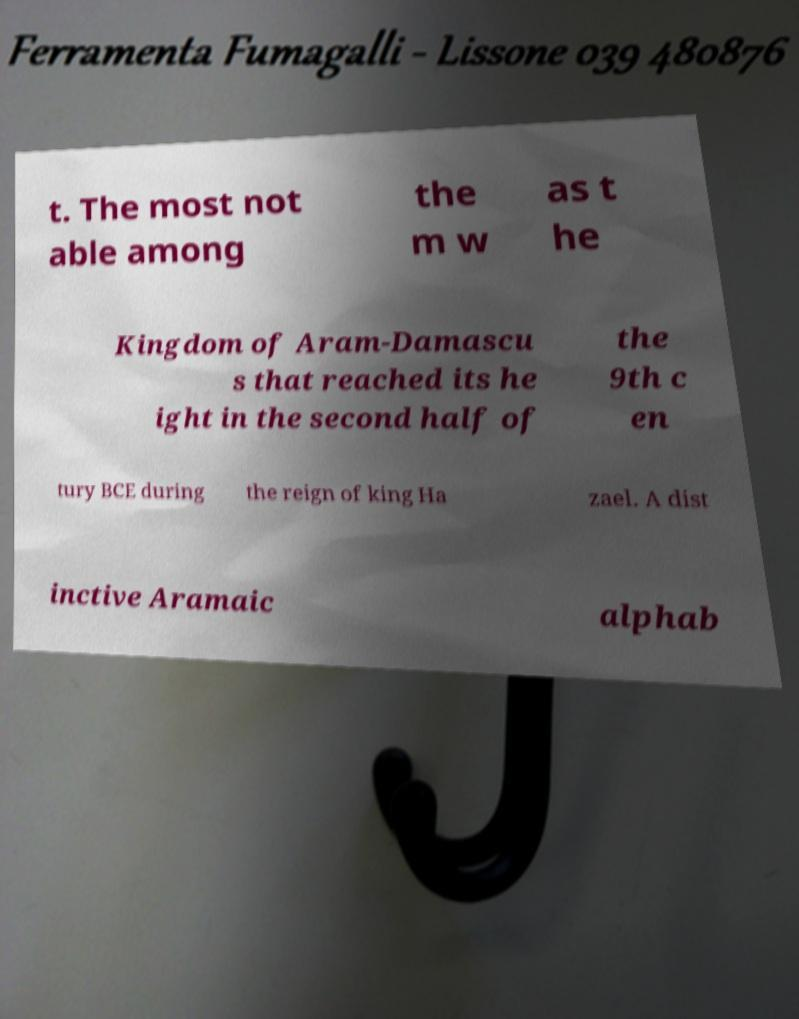What messages or text are displayed in this image? I need them in a readable, typed format. t. The most not able among the m w as t he Kingdom of Aram-Damascu s that reached its he ight in the second half of the 9th c en tury BCE during the reign of king Ha zael. A dist inctive Aramaic alphab 